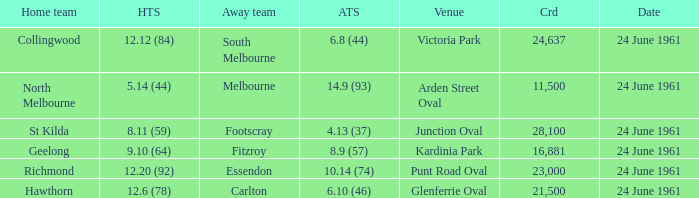What was the home team's score at the game with a crowd of more than 24,637? 8.11 (59). Could you parse the entire table? {'header': ['Home team', 'HTS', 'Away team', 'ATS', 'Venue', 'Crd', 'Date'], 'rows': [['Collingwood', '12.12 (84)', 'South Melbourne', '6.8 (44)', 'Victoria Park', '24,637', '24 June 1961'], ['North Melbourne', '5.14 (44)', 'Melbourne', '14.9 (93)', 'Arden Street Oval', '11,500', '24 June 1961'], ['St Kilda', '8.11 (59)', 'Footscray', '4.13 (37)', 'Junction Oval', '28,100', '24 June 1961'], ['Geelong', '9.10 (64)', 'Fitzroy', '8.9 (57)', 'Kardinia Park', '16,881', '24 June 1961'], ['Richmond', '12.20 (92)', 'Essendon', '10.14 (74)', 'Punt Road Oval', '23,000', '24 June 1961'], ['Hawthorn', '12.6 (78)', 'Carlton', '6.10 (46)', 'Glenferrie Oval', '21,500', '24 June 1961']]} 